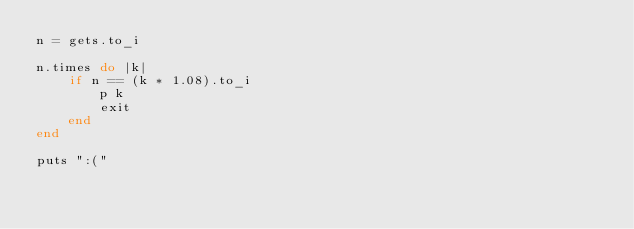Convert code to text. <code><loc_0><loc_0><loc_500><loc_500><_Ruby_>n = gets.to_i

n.times do |k|
    if n == (k * 1.08).to_i
        p k
        exit
    end
end

puts ":("</code> 